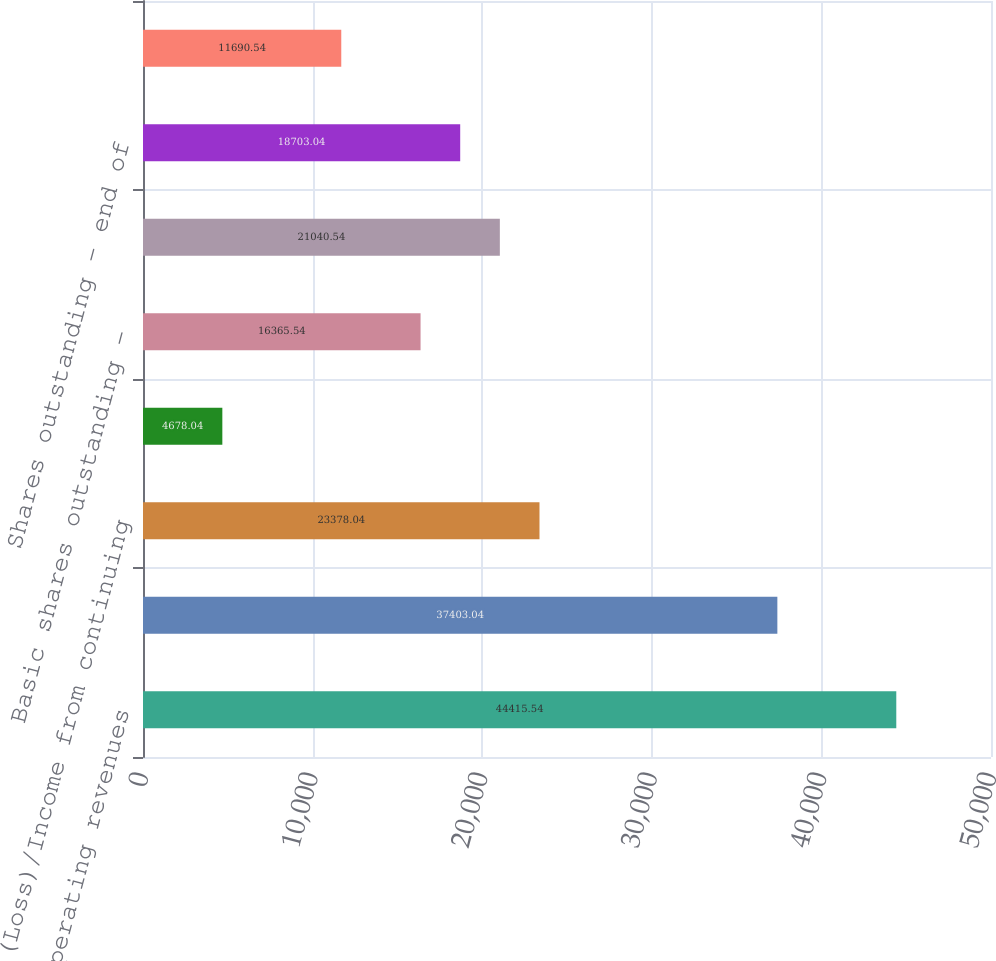Convert chart to OTSL. <chart><loc_0><loc_0><loc_500><loc_500><bar_chart><fcel>Total operating revenues<fcel>Total operating costs and<fcel>(Loss)/Income from continuing<fcel>Net (loss)/income attributable<fcel>Basic shares outstanding -<fcel>Diluted shares outstanding -<fcel>Shares outstanding - end of<fcel>Book value<nl><fcel>44415.5<fcel>37403<fcel>23378<fcel>4678.04<fcel>16365.5<fcel>21040.5<fcel>18703<fcel>11690.5<nl></chart> 